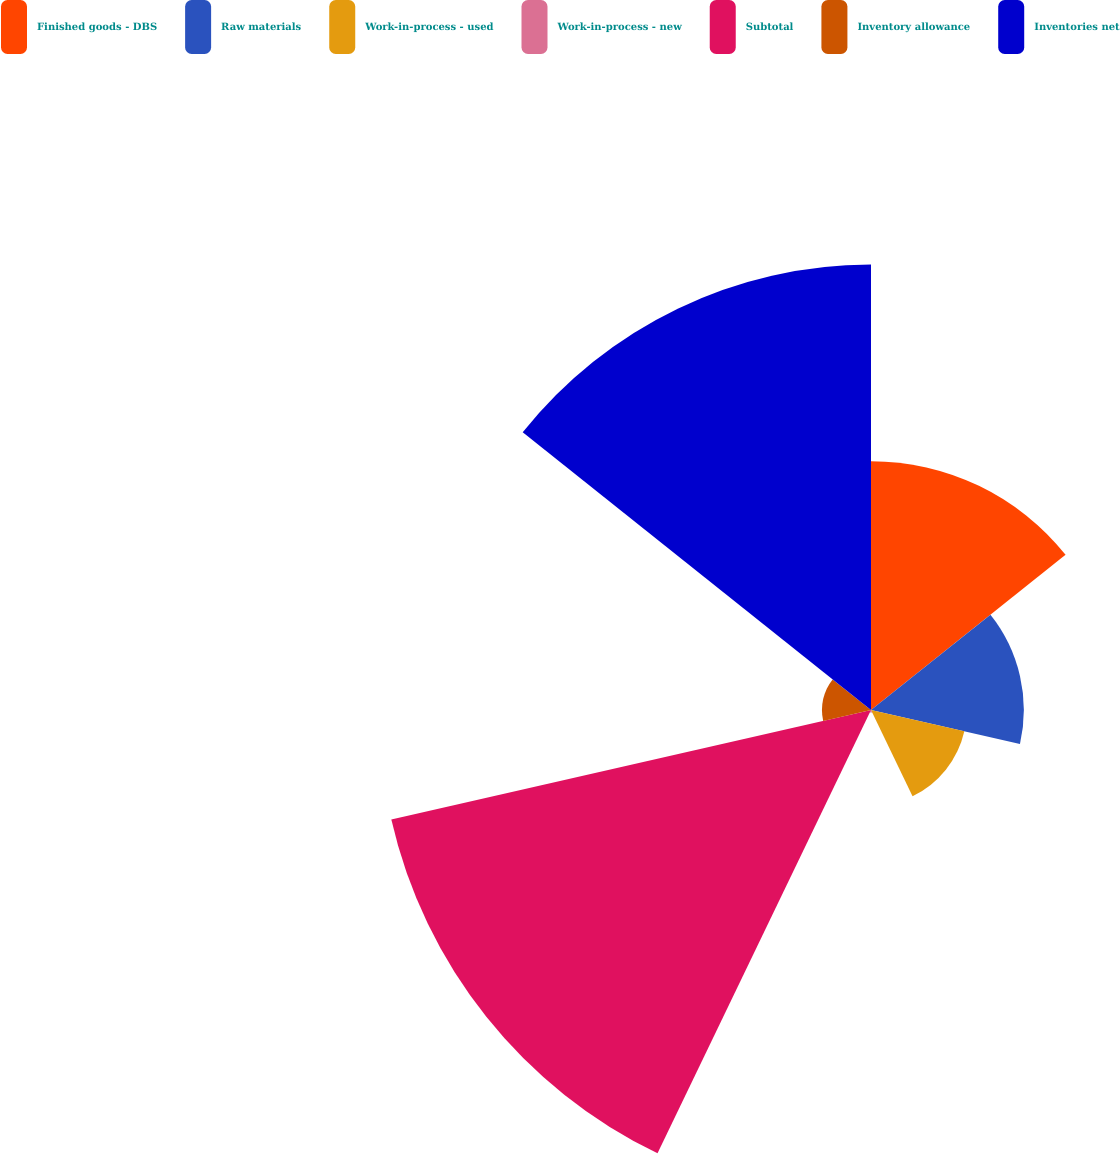Convert chart. <chart><loc_0><loc_0><loc_500><loc_500><pie_chart><fcel>Finished goods - DBS<fcel>Raw materials<fcel>Work-in-process - used<fcel>Work-in-process - new<fcel>Subtotal<fcel>Inventory allowance<fcel>Inventories net<nl><fcel>16.74%<fcel>10.28%<fcel>6.44%<fcel>0.17%<fcel>33.1%<fcel>3.3%<fcel>29.97%<nl></chart> 